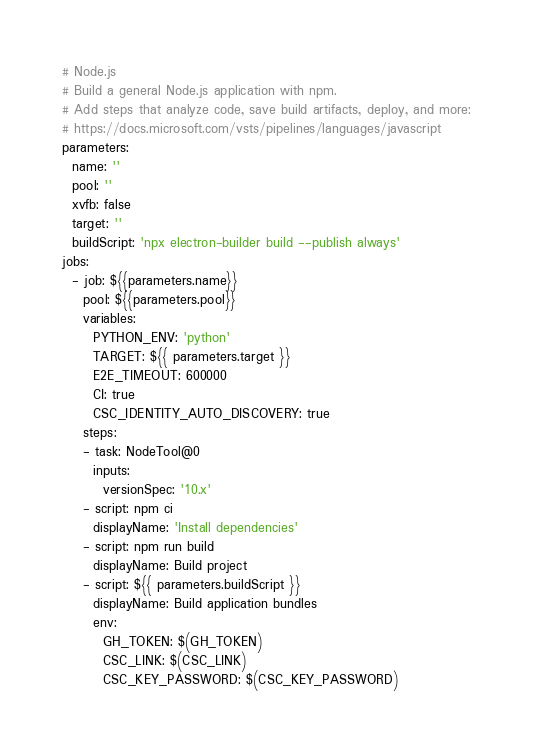<code> <loc_0><loc_0><loc_500><loc_500><_YAML_># Node.js
# Build a general Node.js application with npm.
# Add steps that analyze code, save build artifacts, deploy, and more:
# https://docs.microsoft.com/vsts/pipelines/languages/javascript
parameters:
  name: ''
  pool: ''
  xvfb: false
  target: ''
  buildScript: 'npx electron-builder build --publish always'
jobs:
  - job: ${{parameters.name}}
    pool: ${{parameters.pool}}
    variables:
      PYTHON_ENV: 'python'
      TARGET: ${{ parameters.target }}
      E2E_TIMEOUT: 600000
      CI: true
      CSC_IDENTITY_AUTO_DISCOVERY: true
    steps:
    - task: NodeTool@0
      inputs:
        versionSpec: '10.x'
    - script: npm ci
      displayName: 'Install dependencies'
    - script: npm run build
      displayName: Build project
    - script: ${{ parameters.buildScript }}
      displayName: Build application bundles
      env:
        GH_TOKEN: $(GH_TOKEN)
        CSC_LINK: $(CSC_LINK)
        CSC_KEY_PASSWORD: $(CSC_KEY_PASSWORD)
</code> 